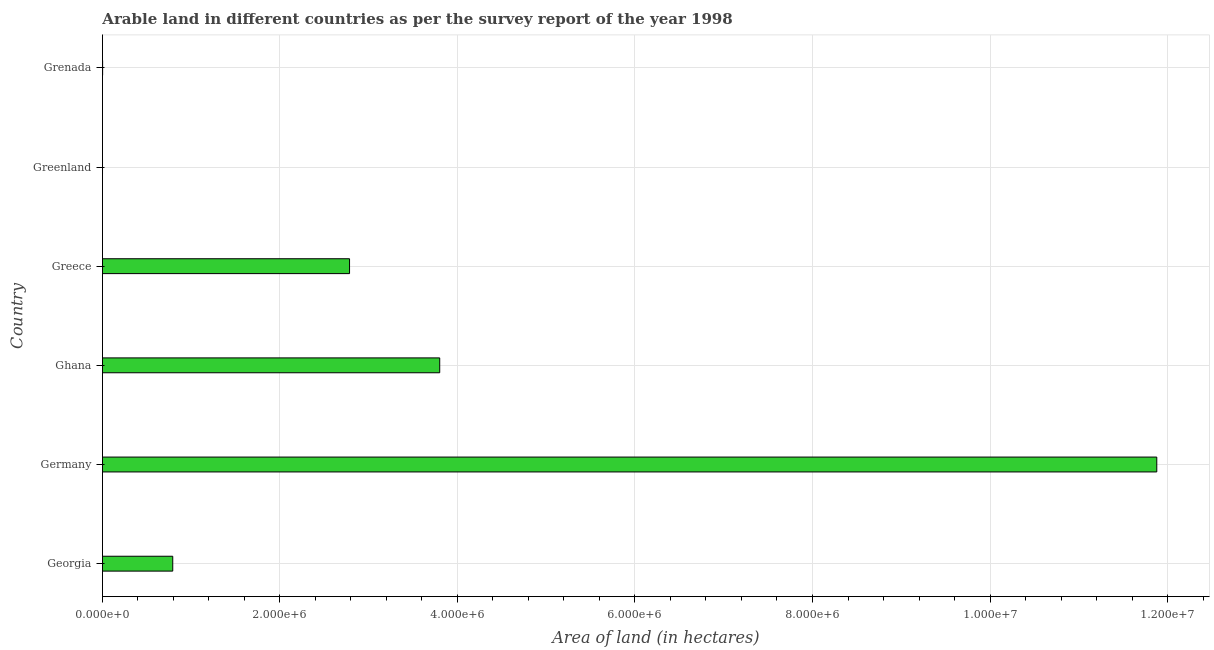Does the graph contain any zero values?
Your response must be concise. No. What is the title of the graph?
Give a very brief answer. Arable land in different countries as per the survey report of the year 1998. What is the label or title of the X-axis?
Keep it short and to the point. Area of land (in hectares). What is the label or title of the Y-axis?
Give a very brief answer. Country. What is the area of land in Germany?
Offer a very short reply. 1.19e+07. Across all countries, what is the maximum area of land?
Make the answer very short. 1.19e+07. Across all countries, what is the minimum area of land?
Ensure brevity in your answer.  700. In which country was the area of land maximum?
Ensure brevity in your answer.  Germany. In which country was the area of land minimum?
Offer a terse response. Greenland. What is the sum of the area of land?
Your answer should be very brief. 1.93e+07. What is the difference between the area of land in Germany and Grenada?
Ensure brevity in your answer.  1.19e+07. What is the average area of land per country?
Your response must be concise. 3.21e+06. What is the median area of land?
Offer a terse response. 1.79e+06. In how many countries, is the area of land greater than 3600000 hectares?
Your answer should be compact. 2. What is the ratio of the area of land in Georgia to that in Grenada?
Your response must be concise. 396. Is the difference between the area of land in Germany and Grenada greater than the difference between any two countries?
Provide a succinct answer. No. What is the difference between the highest and the second highest area of land?
Ensure brevity in your answer.  8.08e+06. What is the difference between the highest and the lowest area of land?
Make the answer very short. 1.19e+07. In how many countries, is the area of land greater than the average area of land taken over all countries?
Give a very brief answer. 2. How many bars are there?
Offer a terse response. 6. Are all the bars in the graph horizontal?
Provide a short and direct response. Yes. How many countries are there in the graph?
Give a very brief answer. 6. Are the values on the major ticks of X-axis written in scientific E-notation?
Ensure brevity in your answer.  Yes. What is the Area of land (in hectares) of Georgia?
Provide a succinct answer. 7.92e+05. What is the Area of land (in hectares) in Germany?
Your answer should be very brief. 1.19e+07. What is the Area of land (in hectares) of Ghana?
Offer a very short reply. 3.80e+06. What is the Area of land (in hectares) of Greece?
Provide a succinct answer. 2.78e+06. What is the Area of land (in hectares) in Greenland?
Offer a very short reply. 700. What is the difference between the Area of land (in hectares) in Georgia and Germany?
Keep it short and to the point. -1.11e+07. What is the difference between the Area of land (in hectares) in Georgia and Ghana?
Keep it short and to the point. -3.01e+06. What is the difference between the Area of land (in hectares) in Georgia and Greece?
Your answer should be compact. -1.99e+06. What is the difference between the Area of land (in hectares) in Georgia and Greenland?
Keep it short and to the point. 7.91e+05. What is the difference between the Area of land (in hectares) in Georgia and Grenada?
Give a very brief answer. 7.90e+05. What is the difference between the Area of land (in hectares) in Germany and Ghana?
Provide a succinct answer. 8.08e+06. What is the difference between the Area of land (in hectares) in Germany and Greece?
Offer a terse response. 9.10e+06. What is the difference between the Area of land (in hectares) in Germany and Greenland?
Offer a very short reply. 1.19e+07. What is the difference between the Area of land (in hectares) in Germany and Grenada?
Your answer should be very brief. 1.19e+07. What is the difference between the Area of land (in hectares) in Ghana and Greece?
Your answer should be very brief. 1.02e+06. What is the difference between the Area of land (in hectares) in Ghana and Greenland?
Make the answer very short. 3.80e+06. What is the difference between the Area of land (in hectares) in Ghana and Grenada?
Keep it short and to the point. 3.80e+06. What is the difference between the Area of land (in hectares) in Greece and Greenland?
Your answer should be compact. 2.78e+06. What is the difference between the Area of land (in hectares) in Greece and Grenada?
Keep it short and to the point. 2.78e+06. What is the difference between the Area of land (in hectares) in Greenland and Grenada?
Give a very brief answer. -1300. What is the ratio of the Area of land (in hectares) in Georgia to that in Germany?
Ensure brevity in your answer.  0.07. What is the ratio of the Area of land (in hectares) in Georgia to that in Ghana?
Your answer should be very brief. 0.21. What is the ratio of the Area of land (in hectares) in Georgia to that in Greece?
Your answer should be very brief. 0.28. What is the ratio of the Area of land (in hectares) in Georgia to that in Greenland?
Your answer should be compact. 1131.43. What is the ratio of the Area of land (in hectares) in Georgia to that in Grenada?
Your response must be concise. 396. What is the ratio of the Area of land (in hectares) in Germany to that in Ghana?
Your response must be concise. 3.13. What is the ratio of the Area of land (in hectares) in Germany to that in Greece?
Offer a terse response. 4.27. What is the ratio of the Area of land (in hectares) in Germany to that in Greenland?
Give a very brief answer. 1.70e+04. What is the ratio of the Area of land (in hectares) in Germany to that in Grenada?
Offer a very short reply. 5939.5. What is the ratio of the Area of land (in hectares) in Ghana to that in Greece?
Ensure brevity in your answer.  1.36. What is the ratio of the Area of land (in hectares) in Ghana to that in Greenland?
Keep it short and to the point. 5428.57. What is the ratio of the Area of land (in hectares) in Ghana to that in Grenada?
Offer a terse response. 1900. What is the ratio of the Area of land (in hectares) in Greece to that in Greenland?
Provide a succinct answer. 3977.14. What is the ratio of the Area of land (in hectares) in Greece to that in Grenada?
Ensure brevity in your answer.  1392. What is the ratio of the Area of land (in hectares) in Greenland to that in Grenada?
Provide a short and direct response. 0.35. 